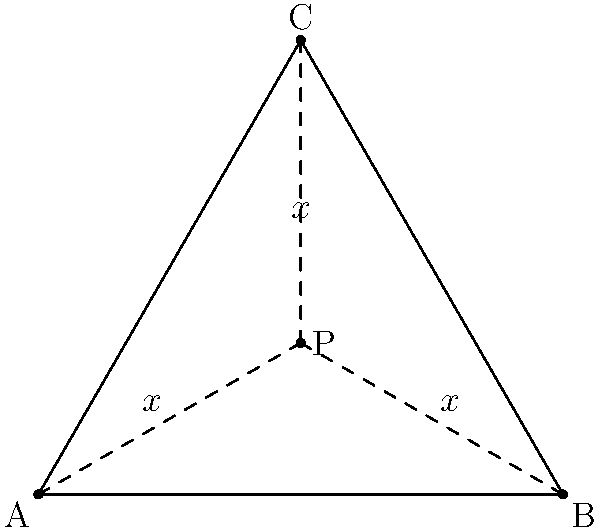In a triangular defensive formation on the basketball court, represented by triangle ABC, a player at point P needs to maintain equal distances from all three corners of the formation. If the side length of the triangle is 100 units, what is the optimal distance x that the player should maintain from each corner to maximize defensive coverage while staying equidistant from A, B, and C? Let's approach this step-by-step:

1) First, we recognize that point P is the centroid of the equilateral triangle ABC. The centroid divides each median in the ratio 2:1, with the longer segment closer to the vertex.

2) In an equilateral triangle, the centroid is located at 1/3 of the height from the base.

3) The height (h) of an equilateral triangle with side length a is given by:
   $$h = \frac{\sqrt{3}}{2}a$$

4) With a side length of 100 units:
   $$h = \frac{\sqrt{3}}{2} \cdot 100 = 50\sqrt{3} \approx 86.6$$

5) The distance from the centroid to any vertex is 2/3 of the height:
   $$x = \frac{2}{3} \cdot 50\sqrt{3} = \frac{100\sqrt{3}}{3}$$

6) We can simplify this:
   $$x = \frac{100\sqrt{3}}{3} \approx 57.74$$

Therefore, the optimal distance x that the player should maintain from each corner is $\frac{100\sqrt{3}}{3}$ units or approximately 57.74 units.
Answer: $\frac{100\sqrt{3}}{3}$ units 